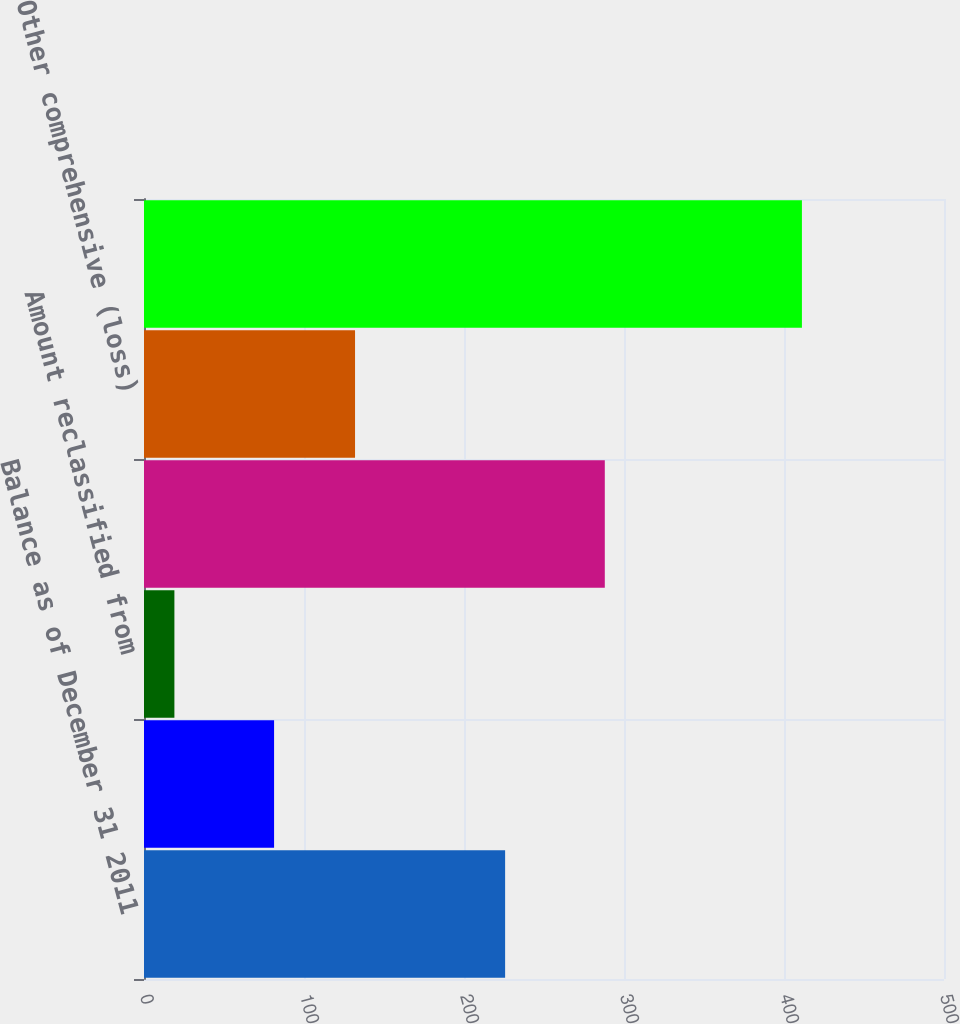Convert chart. <chart><loc_0><loc_0><loc_500><loc_500><bar_chart><fcel>Balance as of December 31 2011<fcel>Other comprehensive income<fcel>Amount reclassified from<fcel>Balance as of December 31 2012<fcel>Other comprehensive (loss)<fcel>Balance as of December 31 2013<nl><fcel>225.7<fcel>81.3<fcel>19<fcel>288<fcel>131.9<fcel>411.2<nl></chart> 